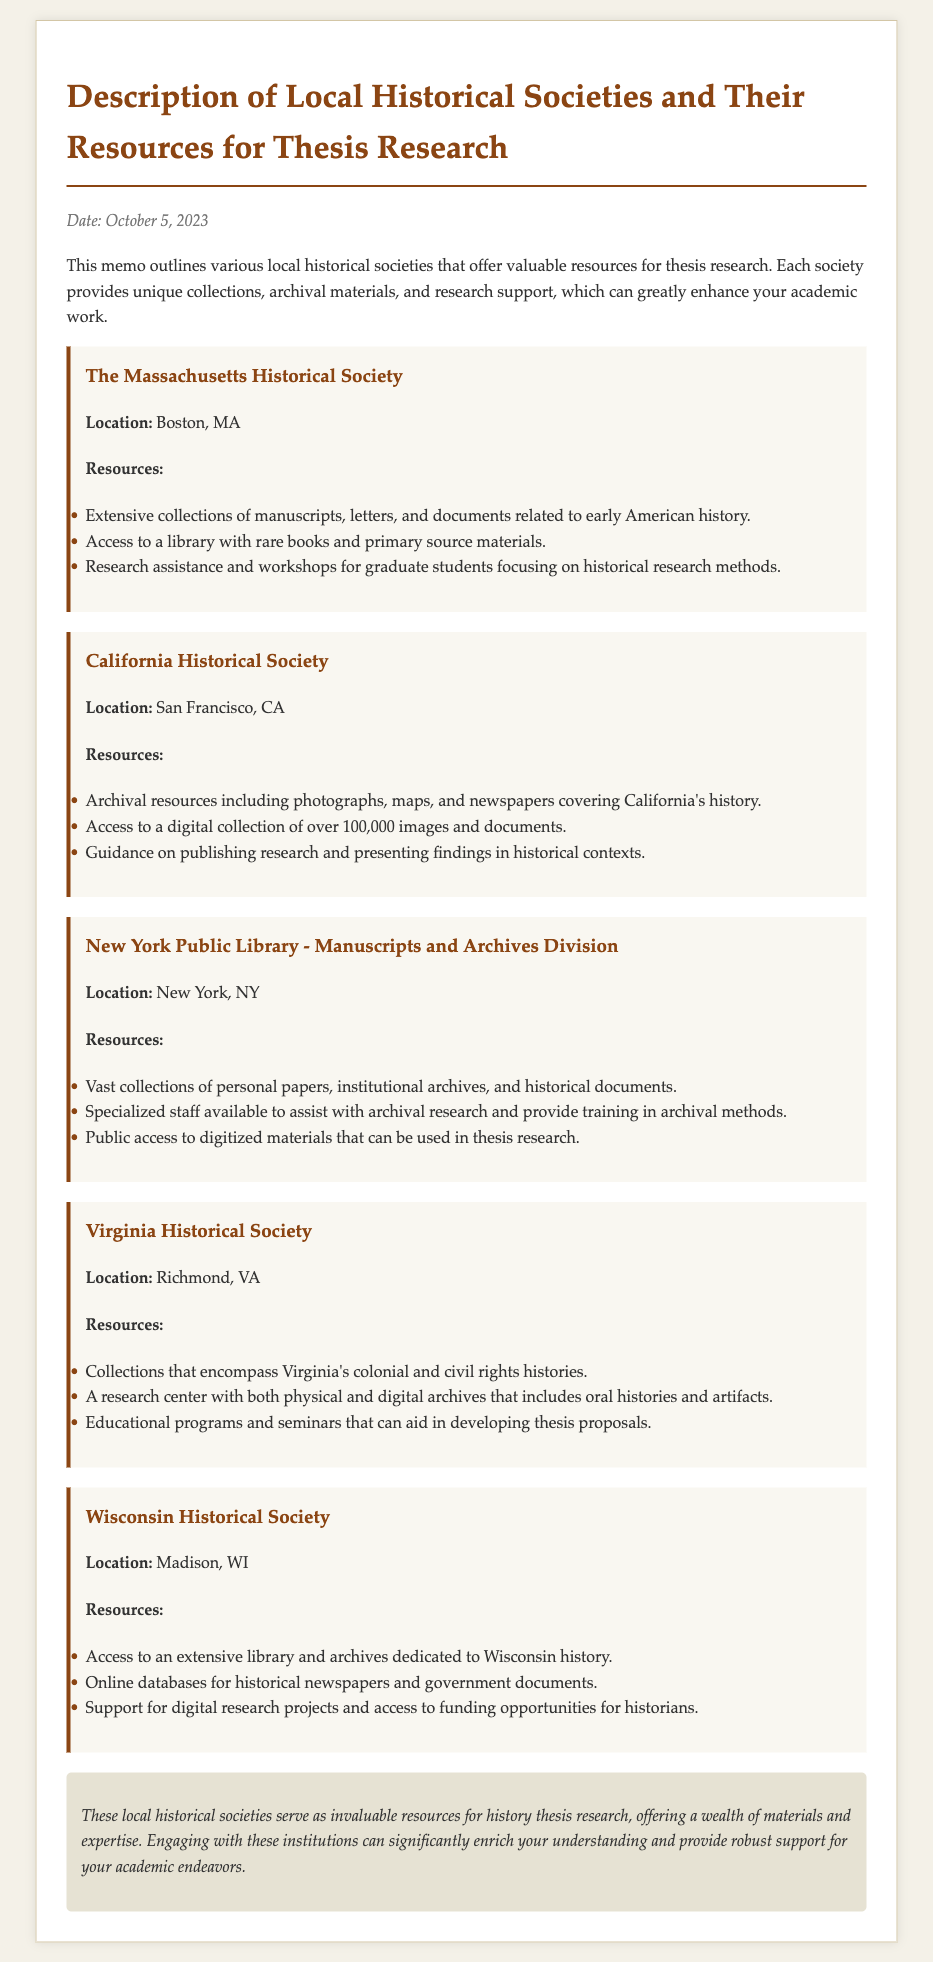What is the date of the memo? The date is explicitly mentioned in the document as the date of creation for the memo.
Answer: October 5, 2023 What is the location of the California Historical Society? This location is provided alongside the society's name in the document for easy reference.
Answer: San Francisco, CA What type of resources does the Wisconsin Historical Society offer? The document specifies the type of resources available at this society.
Answer: Library and archives Which historical society provides digital collections? The memo outlines which societies have digital collections, indicating the one that fits this criterion.
Answer: California Historical Society What kind of training does the New York Public Library offer? The document notes specifically the type of training provided related to archival research.
Answer: Archival methods How many historical images and documents does the California Historical Society have in their digital collection? This question requires combining information regarding the number provided in the document about their digital offerings.
Answer: Over 100,000 images Which society focuses on Virginia's civil rights histories? The specific focus of a society is a key aspect mentioned in the description of resources.
Answer: Virginia Historical Society What type of assistance does the Massachusetts Historical Society provide for graduate students? The document outlines specifically what kind of academic support is available for this demographic.
Answer: Research assistance 